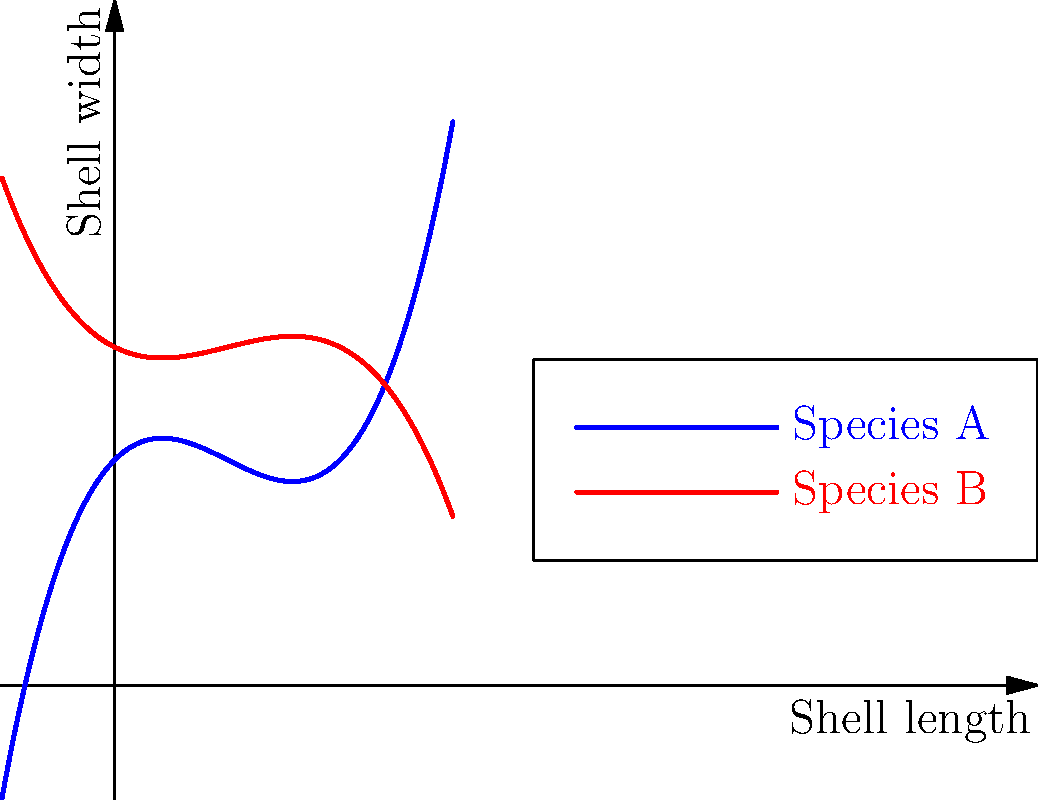The graph shows polynomial shape analysis curves for two mollusk species. Based on the similarity in curve shapes, what evolutionary phenomenon does this likely represent, and what caution should be exercised when interpreting these results? 1. Observe the overall shape of both curves:
   - Both curves show a similar S-shaped pattern
   - They have different coefficients but similar general form

2. Recognize that similar shell shapes can arise in unrelated species:
   - This is often due to similar environmental pressures
   - It's an example of convergent evolution

3. Consider the implications for taxonomy:
   - Similar shapes might lead to misclassification if only morphology is considered
   - Molecular data is crucial for accurate phylogenetic relationships

4. Interpret the graph in context:
   - The x-axis represents shell length, y-axis represents shell width
   - Similar curves suggest similar growth patterns and final shapes

5. Identify the caution needed:
   - Convergent evolution can mask true evolutionary relationships
   - Relying solely on morphological data can lead to incorrect taxonomic conclusions

6. Conclude:
   - The similarity likely represents convergent evolution
   - Caution is needed to avoid misinterpreting morphological similarity as close phylogenetic relationship
Answer: Convergent evolution; caution against assuming close phylogenetic relationship based solely on morphological similarity. 